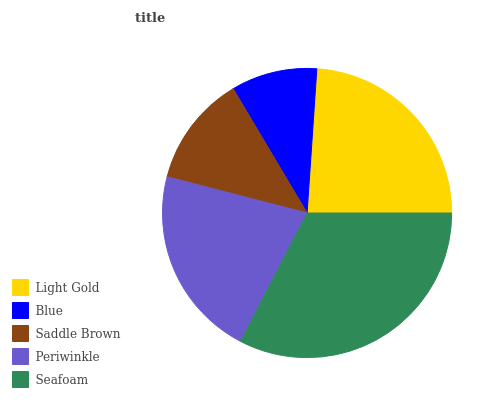Is Blue the minimum?
Answer yes or no. Yes. Is Seafoam the maximum?
Answer yes or no. Yes. Is Saddle Brown the minimum?
Answer yes or no. No. Is Saddle Brown the maximum?
Answer yes or no. No. Is Saddle Brown greater than Blue?
Answer yes or no. Yes. Is Blue less than Saddle Brown?
Answer yes or no. Yes. Is Blue greater than Saddle Brown?
Answer yes or no. No. Is Saddle Brown less than Blue?
Answer yes or no. No. Is Periwinkle the high median?
Answer yes or no. Yes. Is Periwinkle the low median?
Answer yes or no. Yes. Is Saddle Brown the high median?
Answer yes or no. No. Is Light Gold the low median?
Answer yes or no. No. 